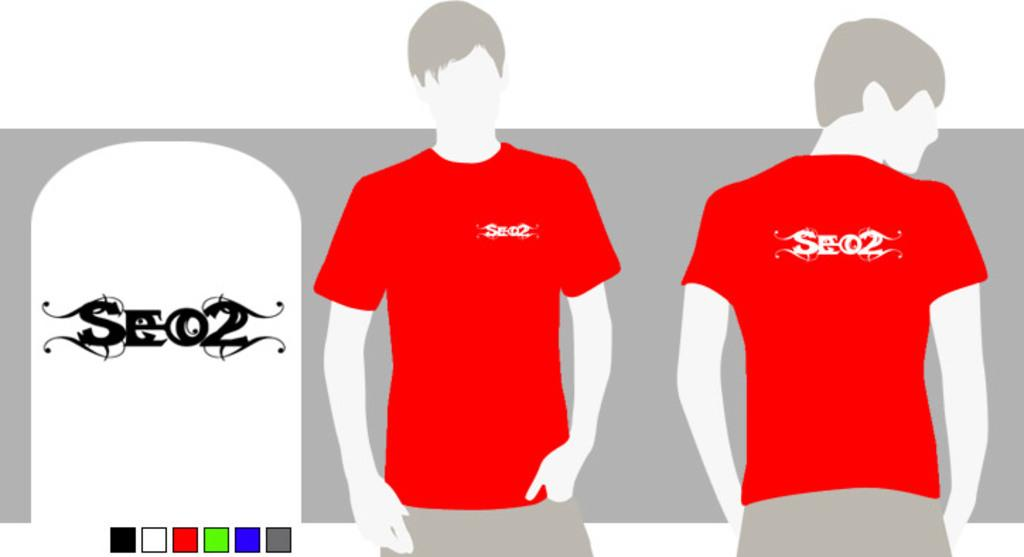<image>
Summarize the visual content of the image. SEO2 is a logo found on t-shirts made for boys. 